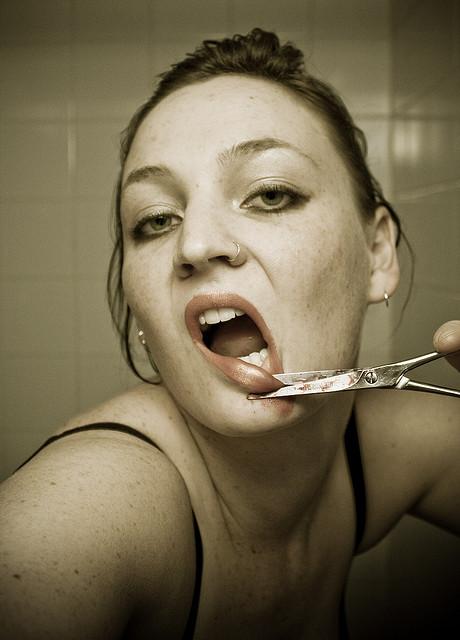Is this woman facing the camera?
Short answer required. Yes. Is the girl wearing jewelry?
Be succinct. Yes. Is she wearing glasses?
Quick response, please. No. Is she cutting her beard?
Answer briefly. No. 